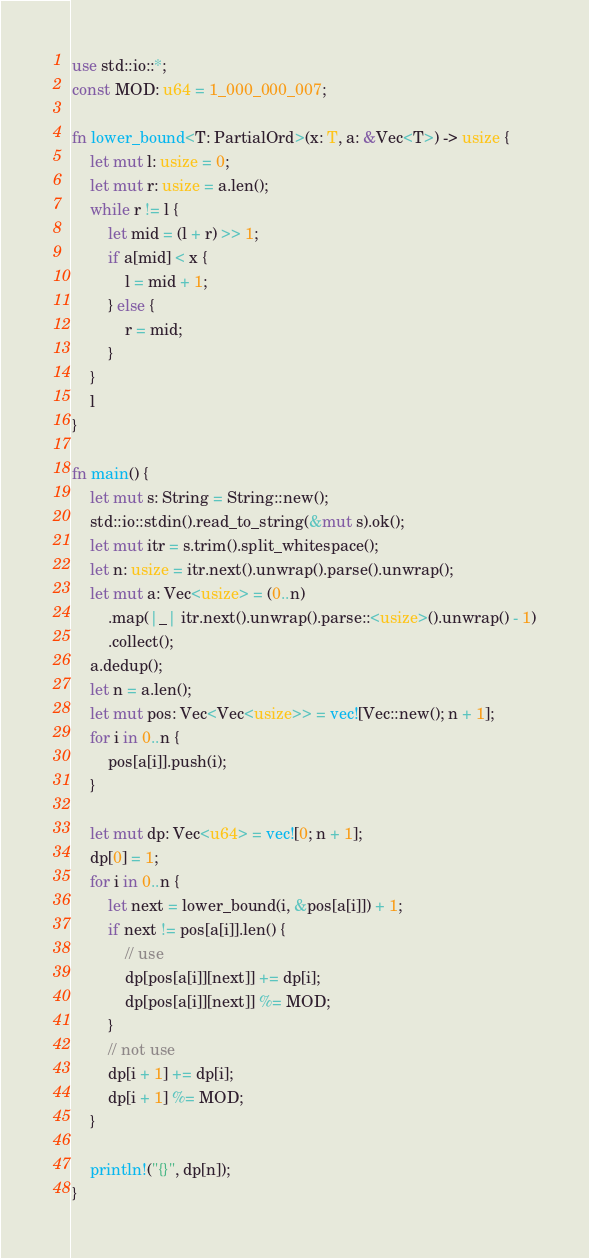Convert code to text. <code><loc_0><loc_0><loc_500><loc_500><_Rust_>use std::io::*;
const MOD: u64 = 1_000_000_007;

fn lower_bound<T: PartialOrd>(x: T, a: &Vec<T>) -> usize {
    let mut l: usize = 0;
    let mut r: usize = a.len();
    while r != l {
        let mid = (l + r) >> 1;
        if a[mid] < x {
            l = mid + 1;
        } else {
            r = mid;
        }
    }
    l
}

fn main() {
    let mut s: String = String::new();
    std::io::stdin().read_to_string(&mut s).ok();
    let mut itr = s.trim().split_whitespace();
    let n: usize = itr.next().unwrap().parse().unwrap();
    let mut a: Vec<usize> = (0..n)
        .map(|_| itr.next().unwrap().parse::<usize>().unwrap() - 1)
        .collect();
    a.dedup();
    let n = a.len();
    let mut pos: Vec<Vec<usize>> = vec![Vec::new(); n + 1];
    for i in 0..n {
        pos[a[i]].push(i);
    }

    let mut dp: Vec<u64> = vec![0; n + 1];
    dp[0] = 1;
    for i in 0..n {
        let next = lower_bound(i, &pos[a[i]]) + 1;
        if next != pos[a[i]].len() {
            // use
            dp[pos[a[i]][next]] += dp[i];
            dp[pos[a[i]][next]] %= MOD;
        }
        // not use
        dp[i + 1] += dp[i];
        dp[i + 1] %= MOD;
    }

    println!("{}", dp[n]);
}
</code> 